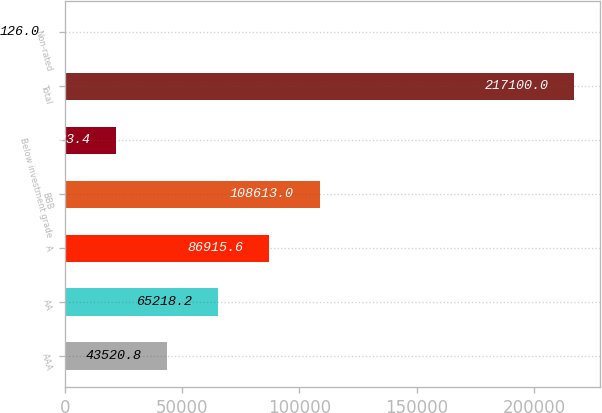<chart> <loc_0><loc_0><loc_500><loc_500><bar_chart><fcel>AAA<fcel>AA<fcel>A<fcel>BBB<fcel>Below investment grade<fcel>Total<fcel>Non-rated<nl><fcel>43520.8<fcel>65218.2<fcel>86915.6<fcel>108613<fcel>21823.4<fcel>217100<fcel>126<nl></chart> 